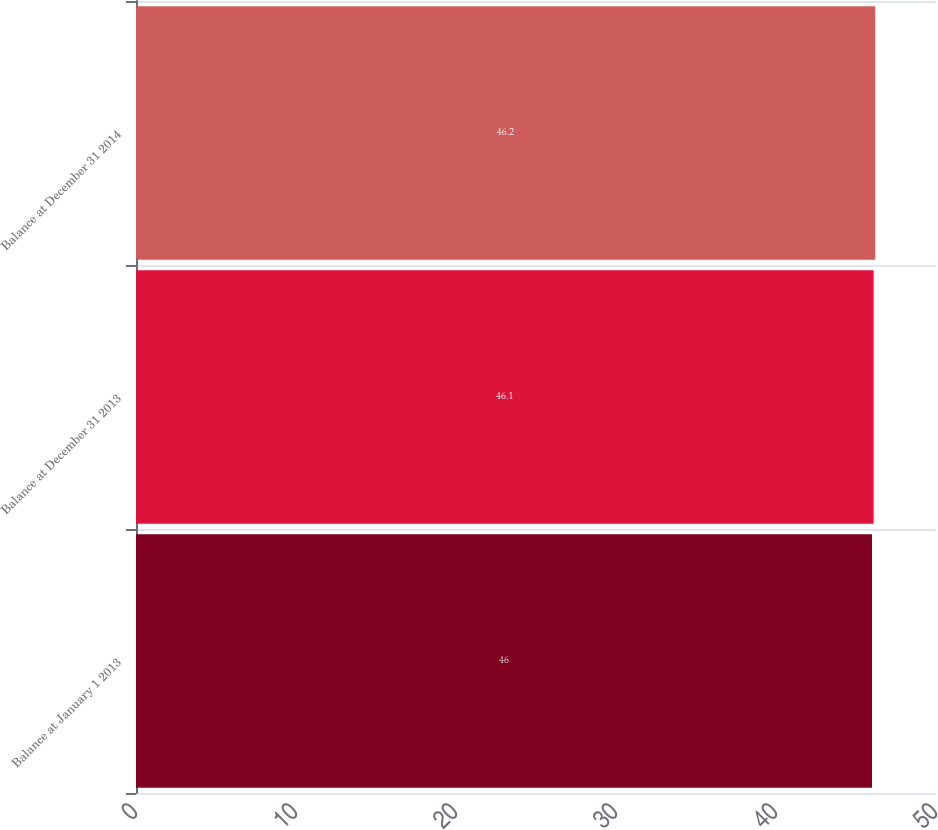<chart> <loc_0><loc_0><loc_500><loc_500><bar_chart><fcel>Balance at January 1 2013<fcel>Balance at December 31 2013<fcel>Balance at December 31 2014<nl><fcel>46<fcel>46.1<fcel>46.2<nl></chart> 